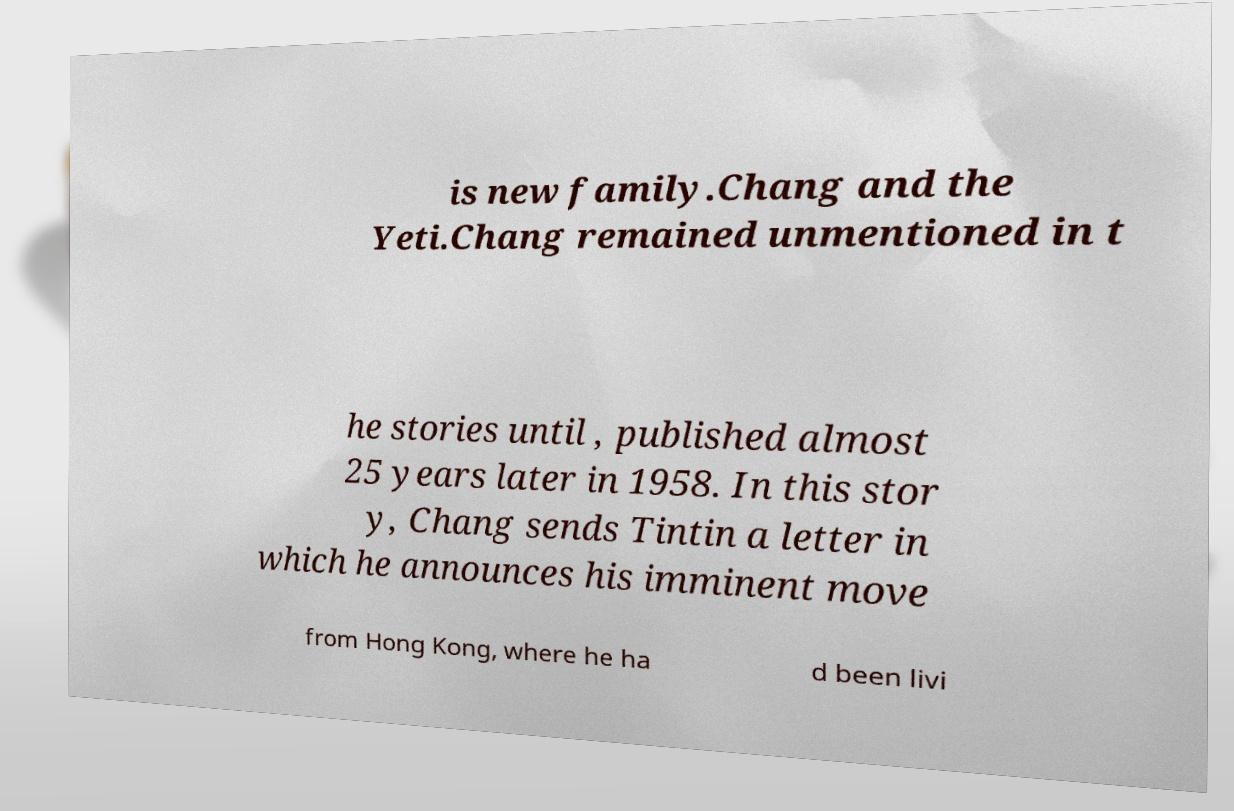There's text embedded in this image that I need extracted. Can you transcribe it verbatim? is new family.Chang and the Yeti.Chang remained unmentioned in t he stories until , published almost 25 years later in 1958. In this stor y, Chang sends Tintin a letter in which he announces his imminent move from Hong Kong, where he ha d been livi 